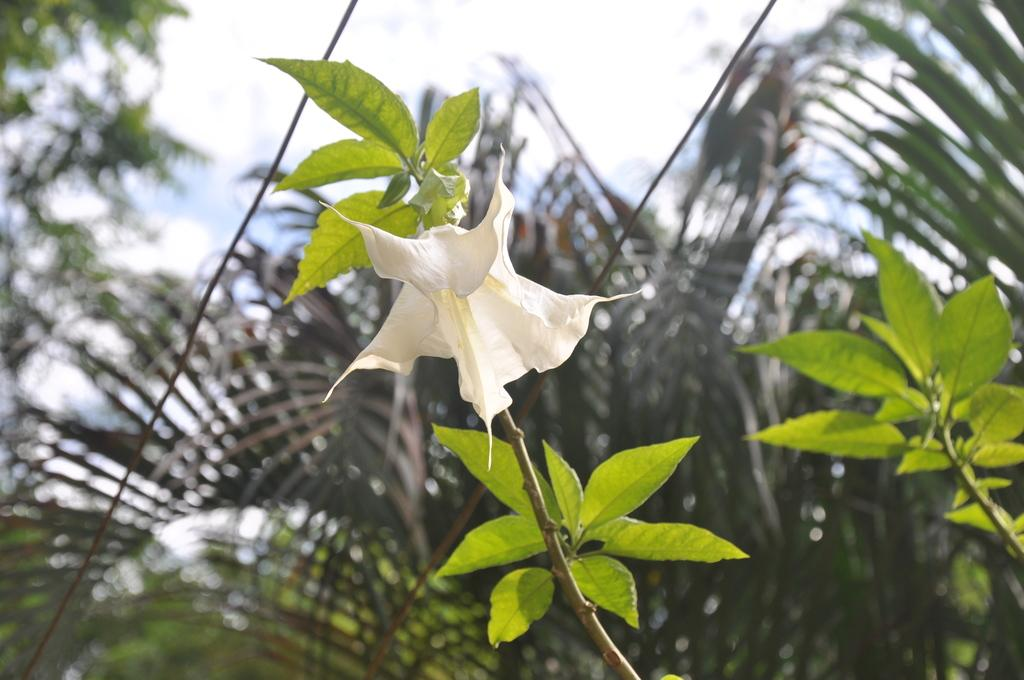What type of plant can be seen in the image? There is a flower in the image. What color are the leaves associated with the flower? There are green leaves in the image. What can be seen in the distance behind the flower? There are trees visible in the background of the image. What type of watch is visible on the flower in the image? There is no watch present on the flower in the image. 